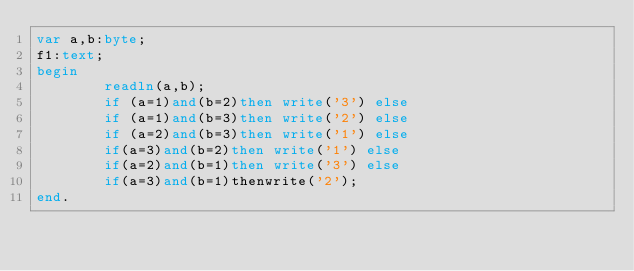<code> <loc_0><loc_0><loc_500><loc_500><_Pascal_>var a,b:byte;
f1:text;
begin
        readln(a,b);
        if (a=1)and(b=2)then write('3') else
        if (a=1)and(b=3)then write('2') else
        if (a=2)and(b=3)then write('1') else
        if(a=3)and(b=2)then write('1') else
        if(a=2)and(b=1)then write('3') else
        if(a=3)and(b=1)thenwrite('2'); 
end.
</code> 